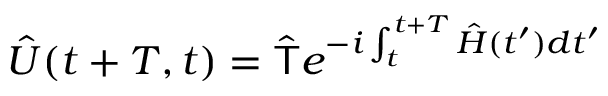Convert formula to latex. <formula><loc_0><loc_0><loc_500><loc_500>\hat { U } ( t + T , t ) = \hat { T } e ^ { - i \int _ { t } ^ { t + T } \hat { H } ( t ^ { \prime } ) d t ^ { \prime } }</formula> 